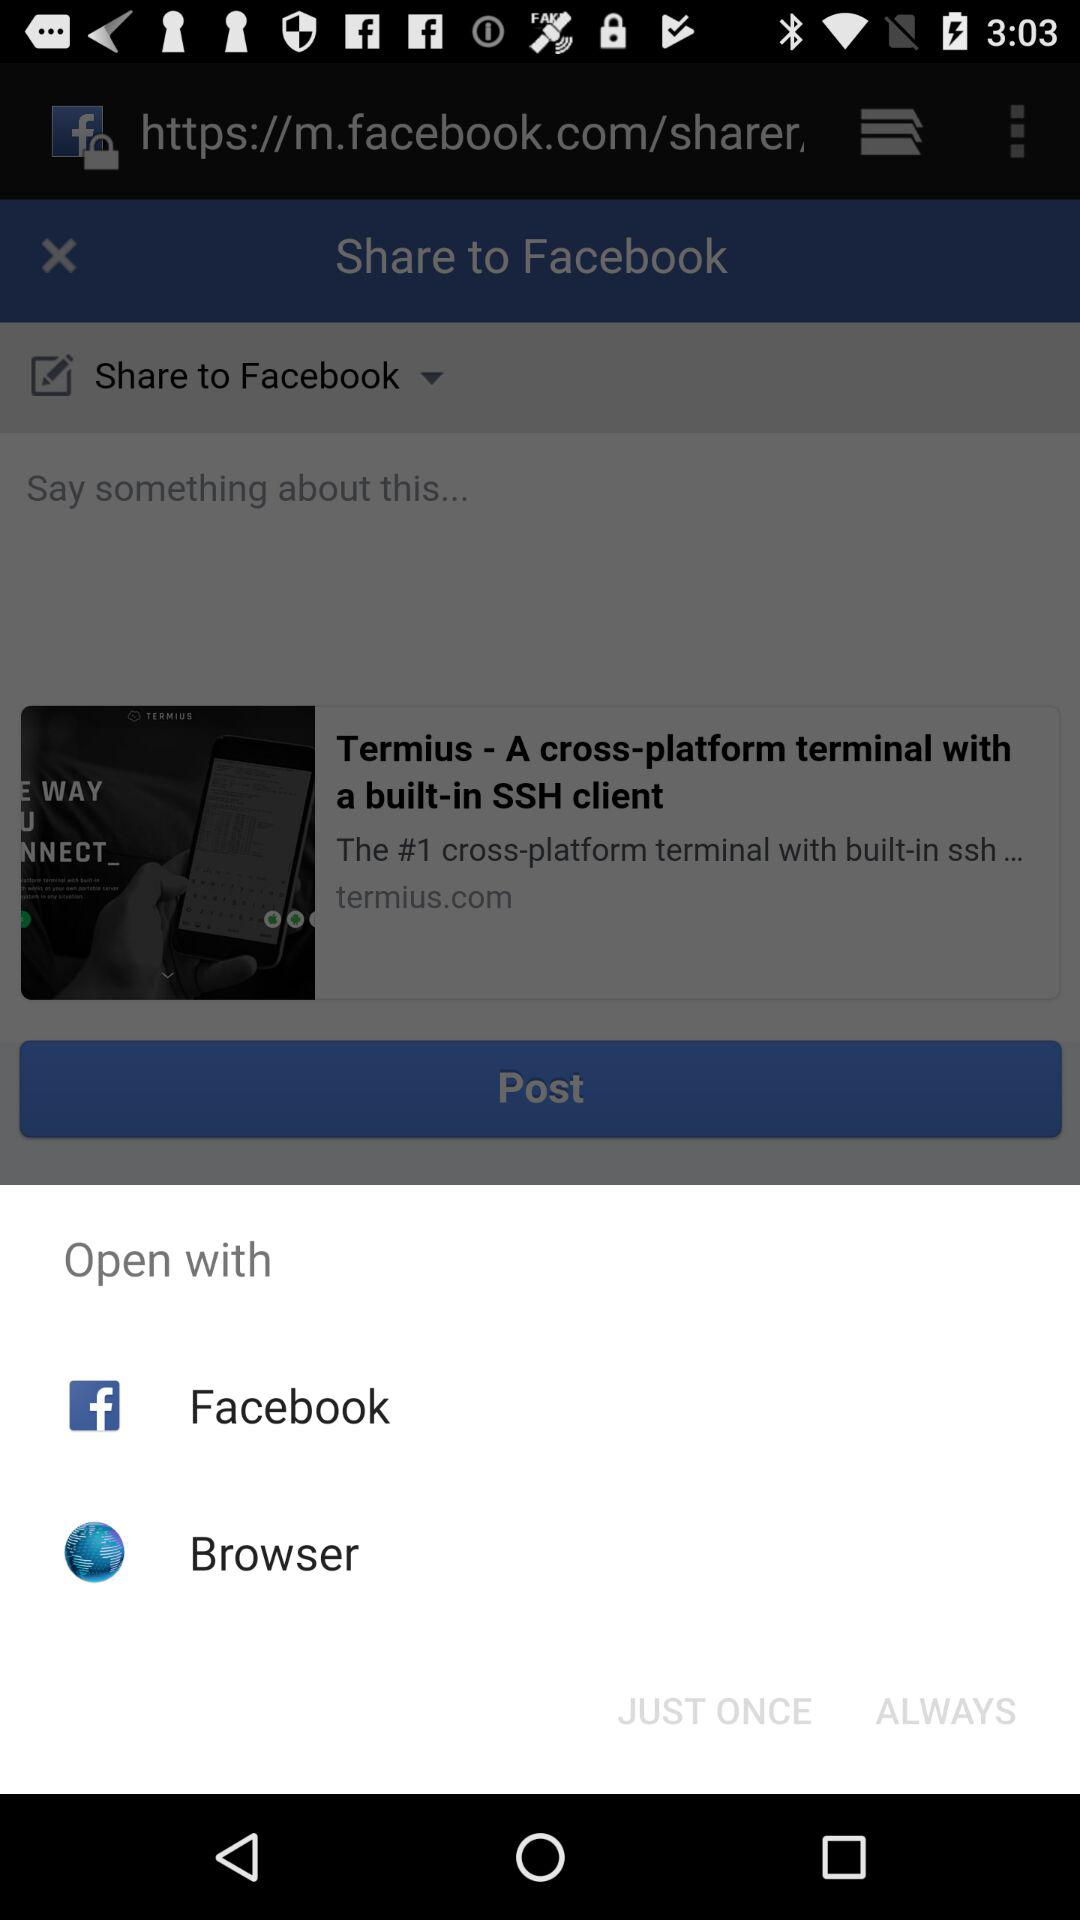What is the name of the application? The name of the application is "Facebook". 